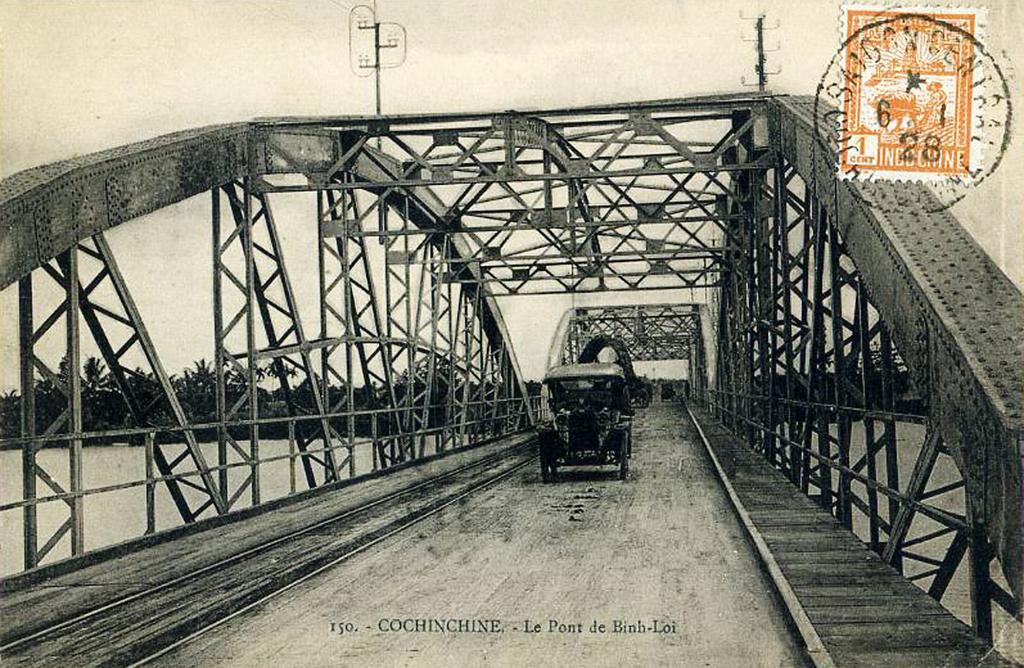How would you summarize this image in a sentence or two? This is a black and white image, in this image there is a bridge, on that bridge there is a car, in the middle there is some text, in the top right there is a stamp, in the background there are trees, under the bridge there is water. 